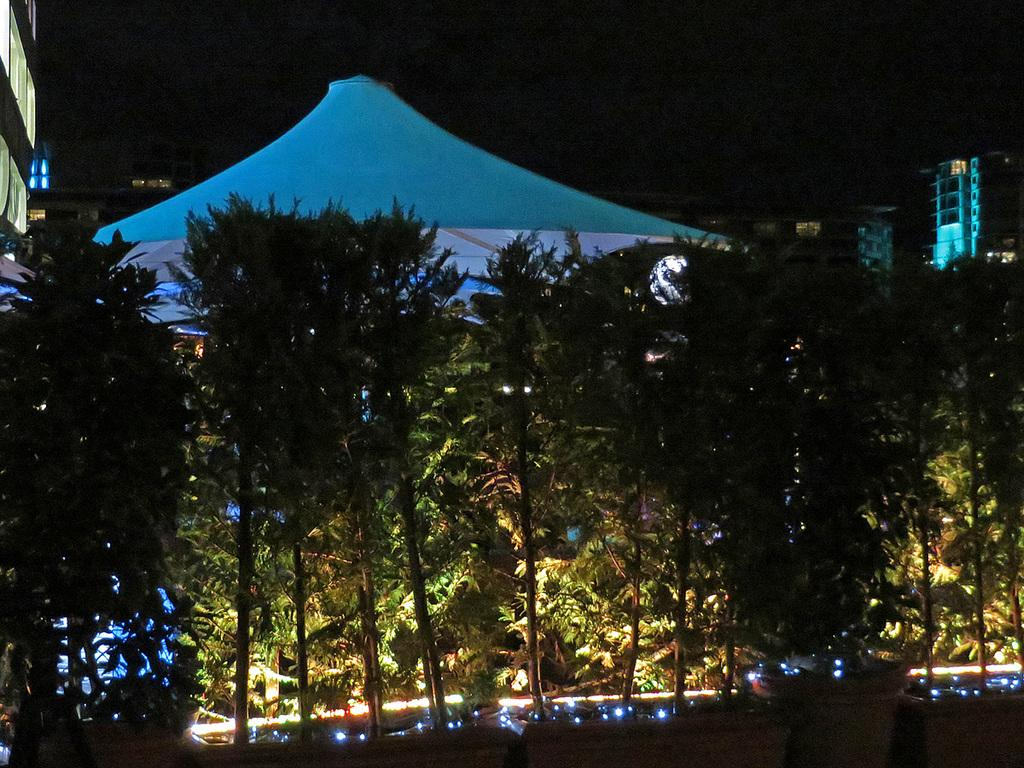What is located in the center of the image? There are trees and a tent in the center of the image. What can be seen at the bottom of the image? There are lights at the bottom of the image. What is visible in the background of the image? There are buildings and the sky in the background of the image. What type of twig is being used to calculate profit in the image? There is no twig or mention of profit in the image; it features trees, a tent, lights, buildings, and the sky. 